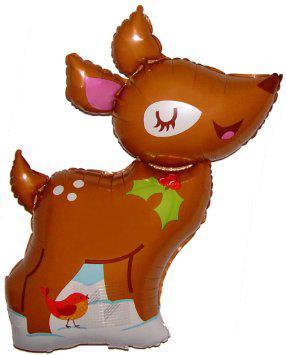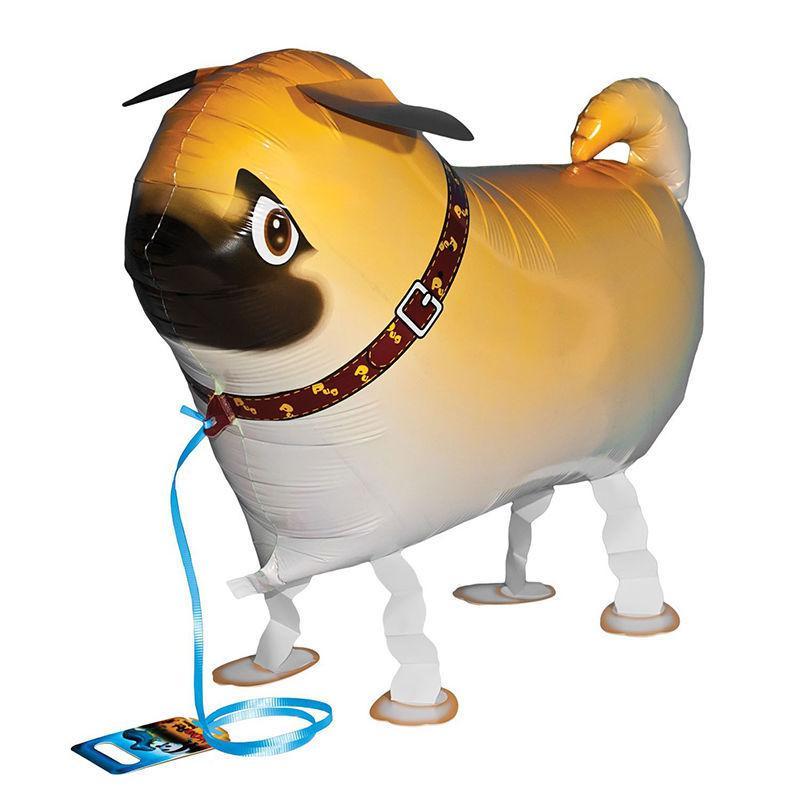The first image is the image on the left, the second image is the image on the right. For the images displayed, is the sentence "One of the balloons is a dog that is wearing a collar and standing on four folded paper legs." factually correct? Answer yes or no. Yes. 